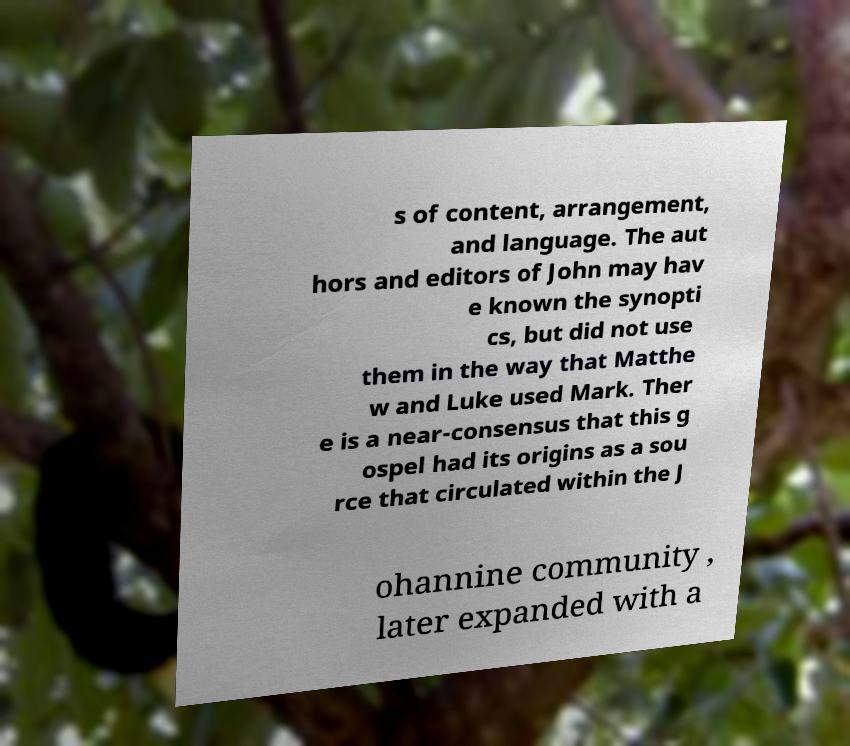For documentation purposes, I need the text within this image transcribed. Could you provide that? s of content, arrangement, and language. The aut hors and editors of John may hav e known the synopti cs, but did not use them in the way that Matthe w and Luke used Mark. Ther e is a near-consensus that this g ospel had its origins as a sou rce that circulated within the J ohannine community , later expanded with a 